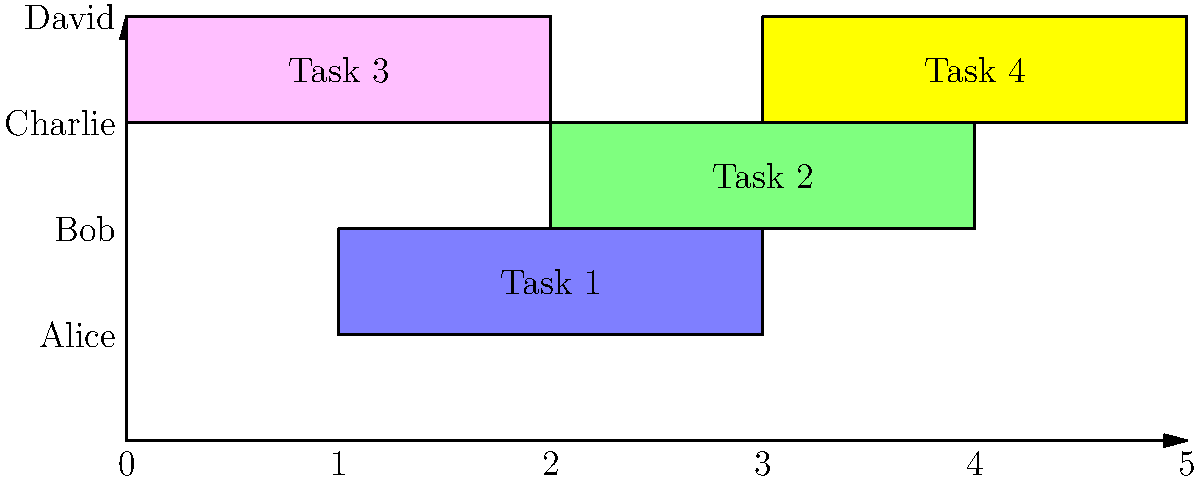As a small business owner, you've created a Gantt chart to schedule your employees for different tasks. Based on the chart, which employee has the longest continuous work period, and how long is it in hours if each unit on the x-axis represents 1 hour? To solve this problem, we need to analyze the Gantt chart for each employee:

1. Alice: Assigned to Task 1, which spans 2 units (100 hours).
2. Bob: Assigned to Task 2, which spans 2 units (100 hours).
3. Charlie: Assigned to two consecutive tasks:
   - Task 3: 2 units
   - Task 4: 2 units
   Total continuous work period for Charlie: 4 units
4. David: Not assigned any tasks.

The employee with the longest continuous work period is Charlie, with 4 units.

Since each unit on the x-axis represents 1 hour, Charlie's longest continuous work period is 4 hours.
Answer: Charlie, 4 hours 